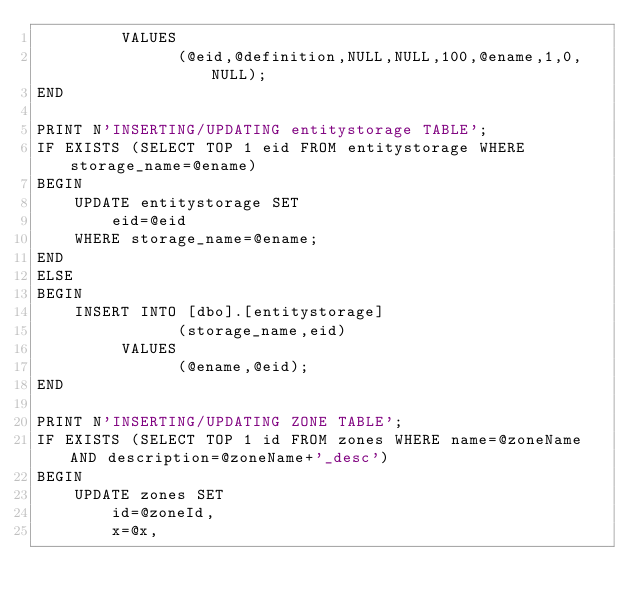Convert code to text. <code><loc_0><loc_0><loc_500><loc_500><_SQL_>		 VALUES
			   (@eid,@definition,NULL,NULL,100,@ename,1,0,NULL);
END

PRINT N'INSERTING/UPDATING entitystorage TABLE';
IF EXISTS (SELECT TOP 1 eid FROM entitystorage WHERE storage_name=@ename)
BEGIN
	UPDATE entitystorage SET
		eid=@eid
	WHERE storage_name=@ename;
END
ELSE
BEGIN
	INSERT INTO [dbo].[entitystorage]
			   (storage_name,eid)
		 VALUES
			   (@ename,@eid);
END

PRINT N'INSERTING/UPDATING ZONE TABLE';
IF EXISTS (SELECT TOP 1 id FROM zones WHERE name=@zoneName AND description=@zoneName+'_desc')
BEGIN
	UPDATE zones SET
		id=@zoneId,
		x=@x,</code> 